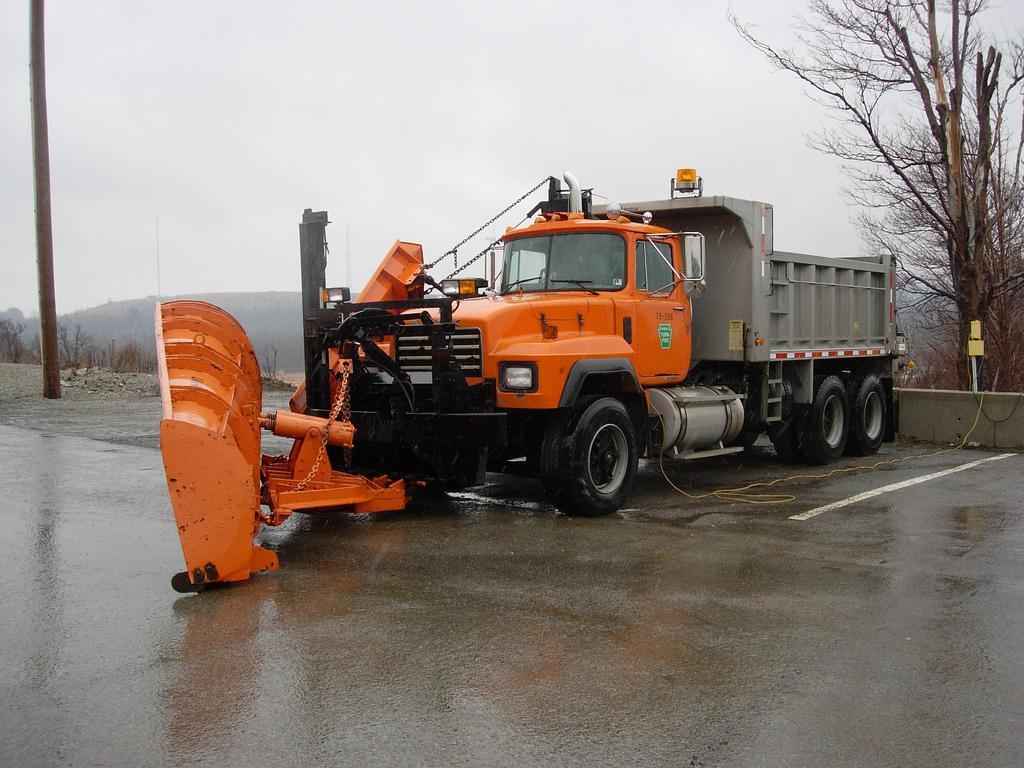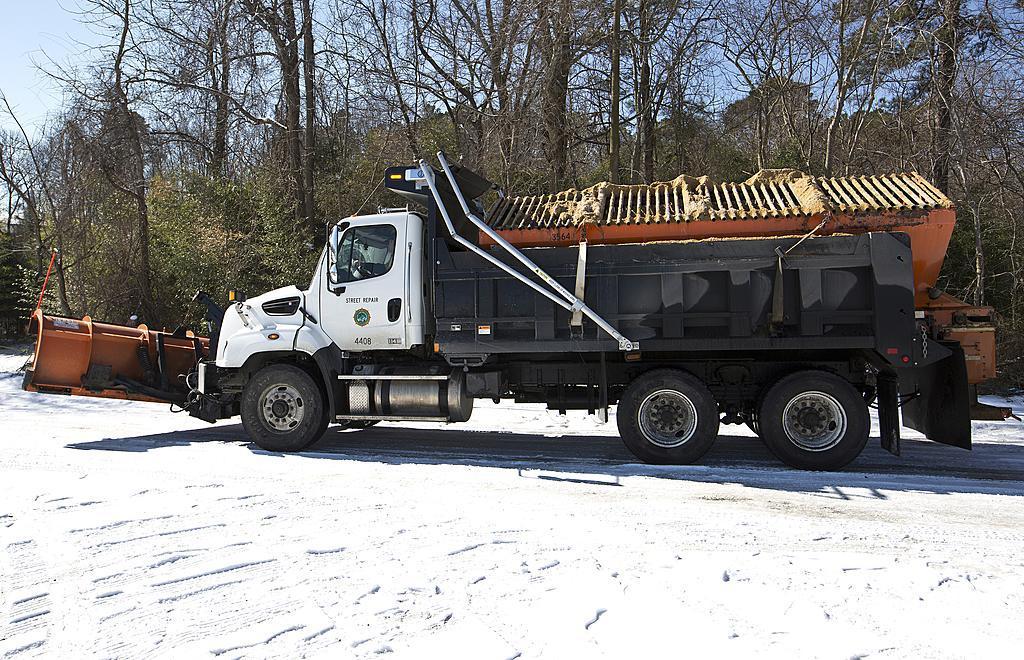The first image is the image on the left, the second image is the image on the right. For the images shown, is this caption "An image features a truck with an orange cab." true? Answer yes or no. Yes. 